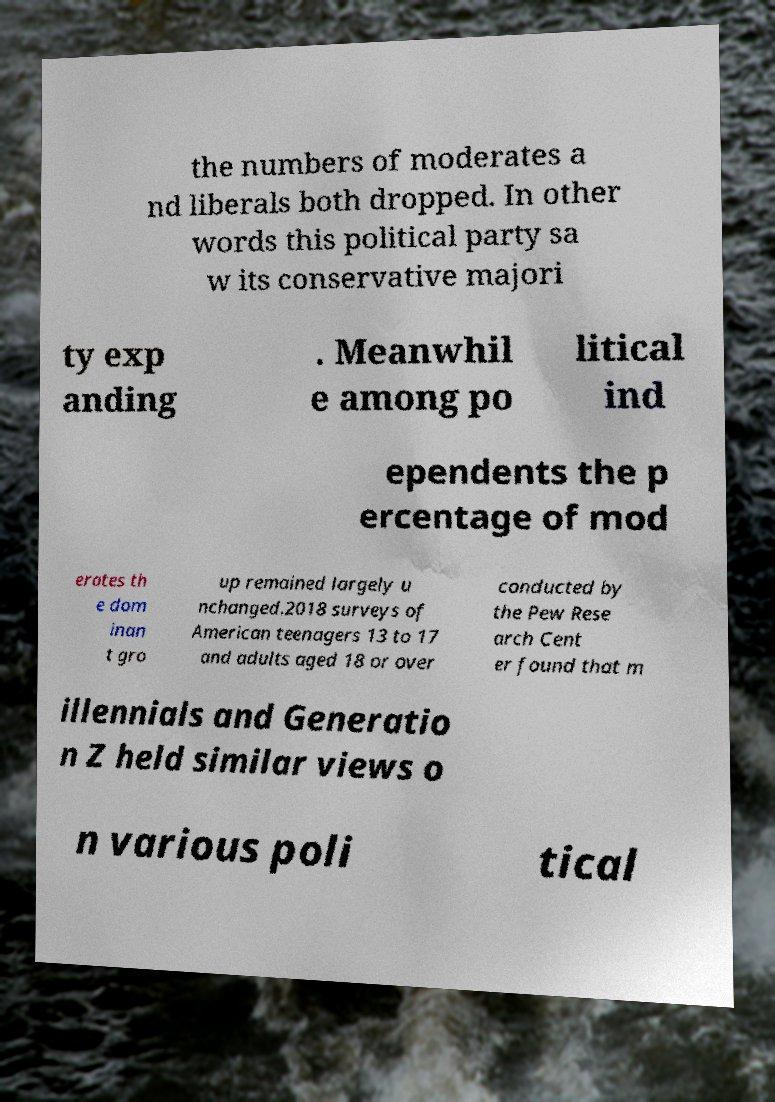Please identify and transcribe the text found in this image. the numbers of moderates a nd liberals both dropped. In other words this political party sa w its conservative majori ty exp anding . Meanwhil e among po litical ind ependents the p ercentage of mod erates th e dom inan t gro up remained largely u nchanged.2018 surveys of American teenagers 13 to 17 and adults aged 18 or over conducted by the Pew Rese arch Cent er found that m illennials and Generatio n Z held similar views o n various poli tical 